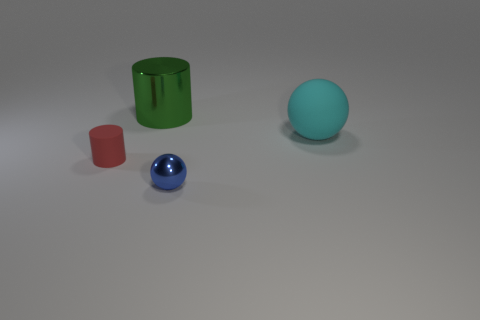Is there anything else of the same color as the tiny matte cylinder?
Offer a terse response. No. What number of green cylinders are there?
Your answer should be compact. 1. What is the material of the big object that is right of the tiny thing to the right of the large green shiny thing?
Give a very brief answer. Rubber. There is a object left of the metallic object that is behind the rubber object that is right of the big green object; what is its color?
Make the answer very short. Red. Is the matte cylinder the same color as the large metal cylinder?
Your answer should be compact. No. What number of green metallic objects are the same size as the cyan rubber ball?
Offer a very short reply. 1. Are there more big green shiny cylinders to the right of the cyan rubber sphere than cyan rubber objects that are to the left of the blue shiny object?
Ensure brevity in your answer.  No. There is a sphere in front of the small object that is left of the green thing; what is its color?
Provide a short and direct response. Blue. Do the big cyan ball and the blue ball have the same material?
Offer a very short reply. No. Are there any other tiny rubber objects that have the same shape as the small red matte object?
Your response must be concise. No. 